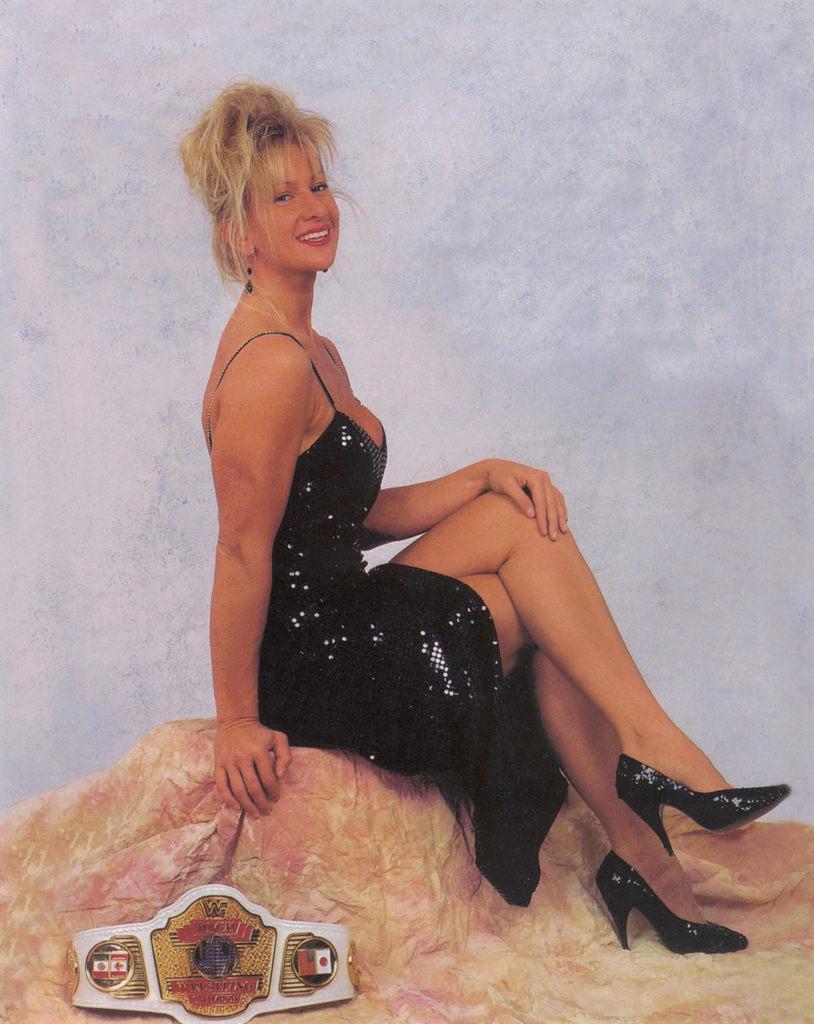Could you give a brief overview of what you see in this image? In this image there is a woman sitting on the rock. She is wearing black dress. Behind her there is a wall. 